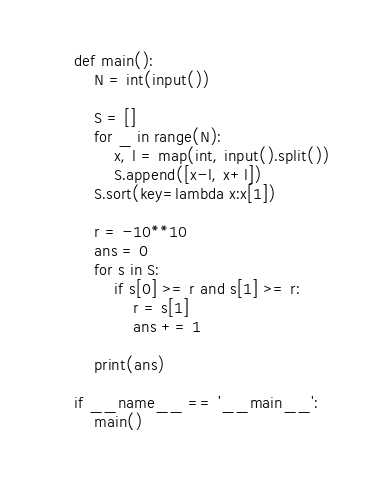Convert code to text. <code><loc_0><loc_0><loc_500><loc_500><_Python_>def main():
    N = int(input())

    S = []
    for _ in range(N):
        x, l = map(int, input().split())
        S.append([x-l, x+l])
    S.sort(key=lambda x:x[1])

    r = -10**10
    ans = 0
    for s in S:
        if s[0] >= r and s[1] >= r:
            r = s[1]
            ans += 1

    print(ans)

if __name__ == '__main__':
    main()</code> 